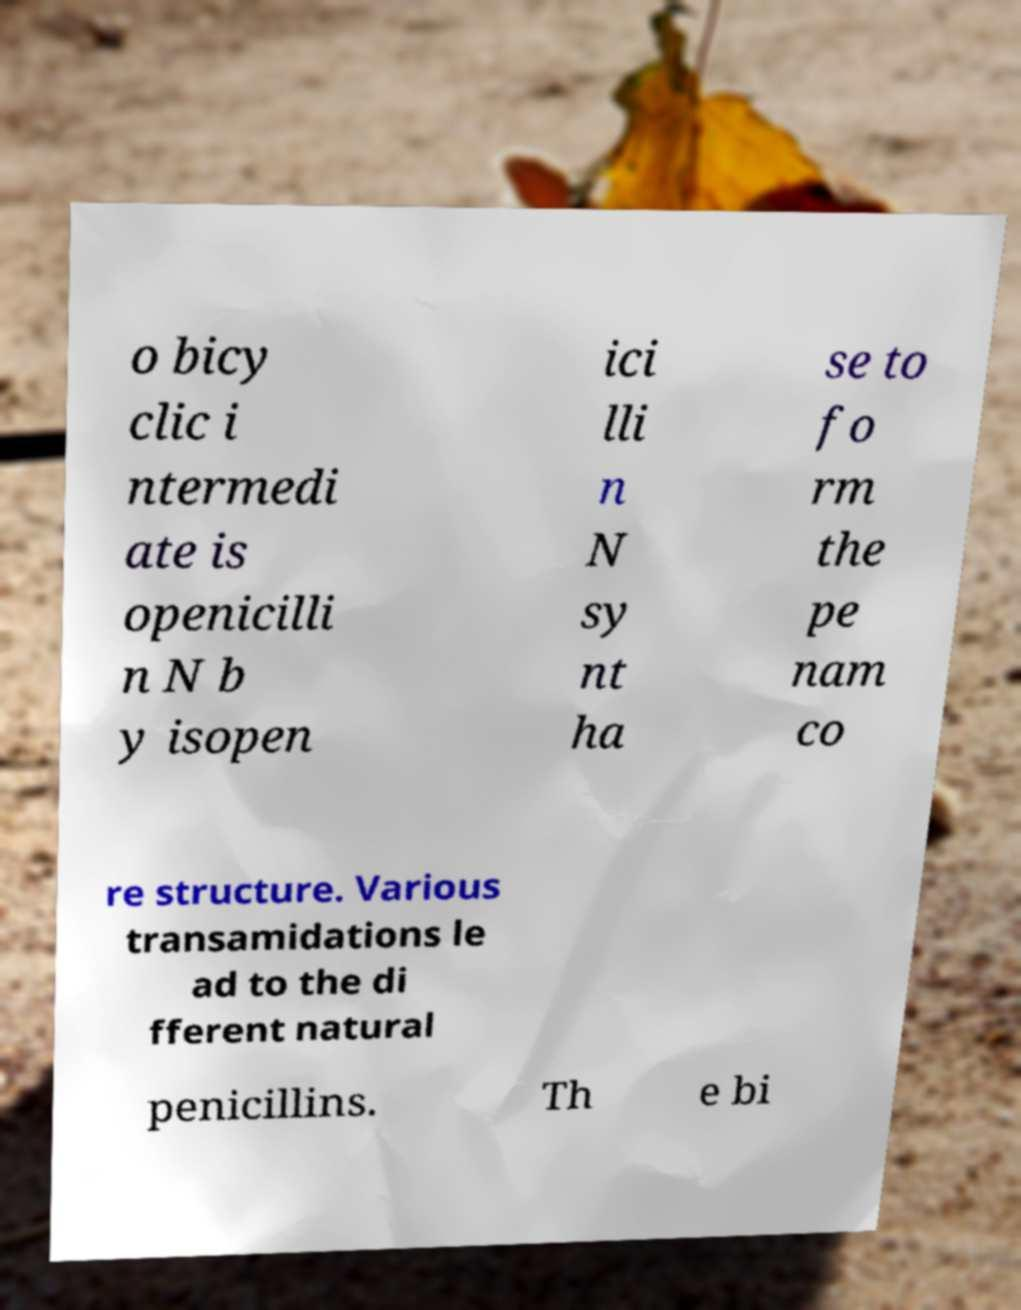There's text embedded in this image that I need extracted. Can you transcribe it verbatim? o bicy clic i ntermedi ate is openicilli n N b y isopen ici lli n N sy nt ha se to fo rm the pe nam co re structure. Various transamidations le ad to the di fferent natural penicillins. Th e bi 